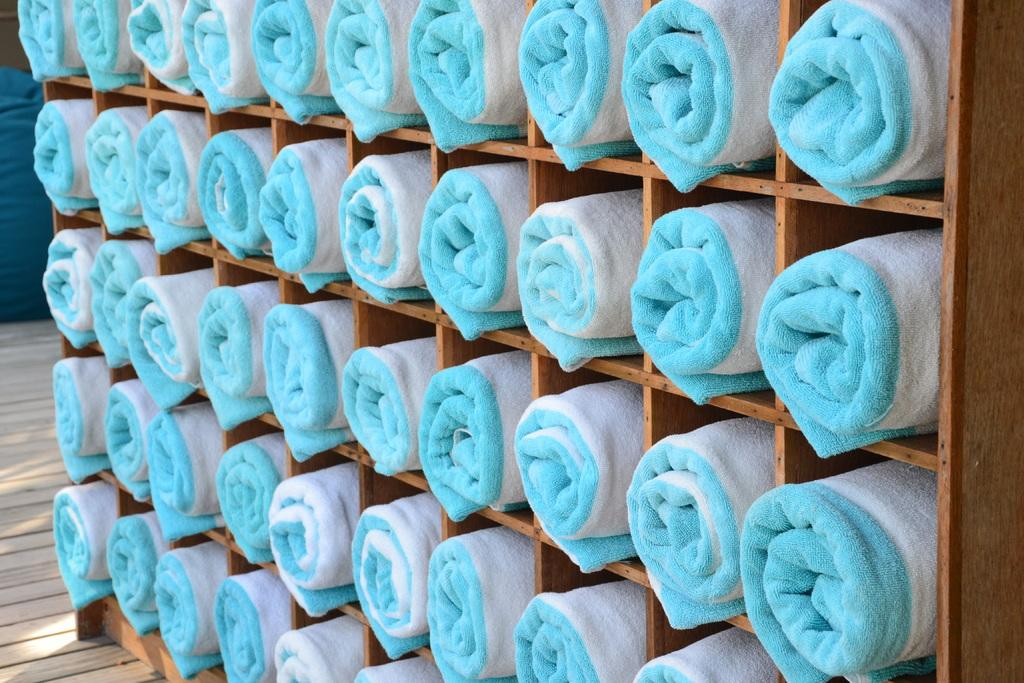What type of item can be seen in the image? There are towels in the image. How are the towels arranged? The towels are rolled and placed in racks. What type of flooring is visible at the bottom of the image? There is wooden flooring at the bottom of the image. Can you tell me how many strands of hair are on the stranger's head in the image? There is no stranger or hair present in the image; it only features rolled towels placed in racks on a wooden floor. 